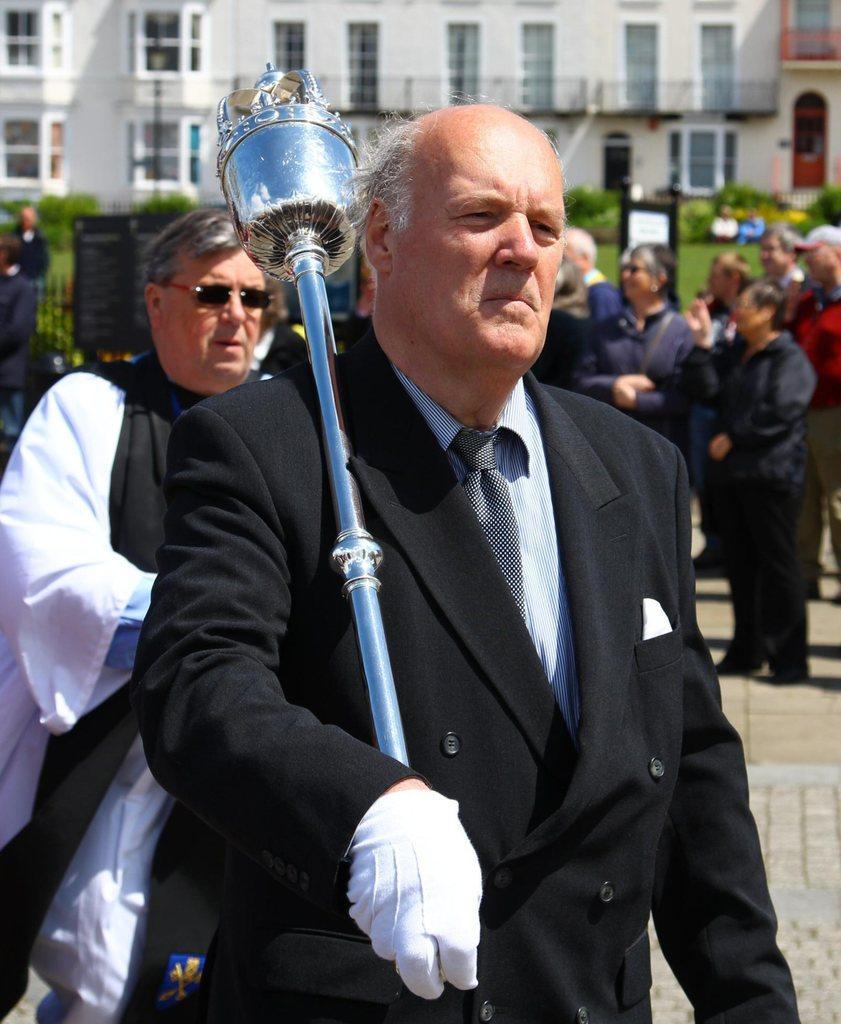In one or two sentences, can you explain what this image depicts? In this picture we can observe a man wearing white color glove and black color coat. He is holding a stick in his hand which is in silver color. Behind him there is a person wearing spectacles. In the background there are some people standing. In the background we can observe some plants and a building which is in white color. 